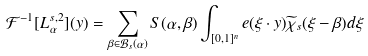Convert formula to latex. <formula><loc_0><loc_0><loc_500><loc_500>\mathcal { F } ^ { - 1 } [ L ^ { s , 2 } _ { \alpha } ] ( y ) = \sum _ { \beta \in \mathcal { B } _ { s } ( \alpha ) } S ( \alpha , \beta ) \int _ { [ 0 , 1 ] ^ { n } } e ( \xi \cdot y ) \widetilde { \chi } _ { s } ( \xi - \beta ) d \xi</formula> 